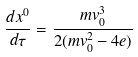Convert formula to latex. <formula><loc_0><loc_0><loc_500><loc_500>\frac { d x ^ { 0 } } { d \tau } = \frac { m v _ { 0 } ^ { 3 } } { 2 ( m v _ { 0 } ^ { 2 } - 4 e ) }</formula> 